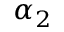Convert formula to latex. <formula><loc_0><loc_0><loc_500><loc_500>\alpha _ { 2 }</formula> 